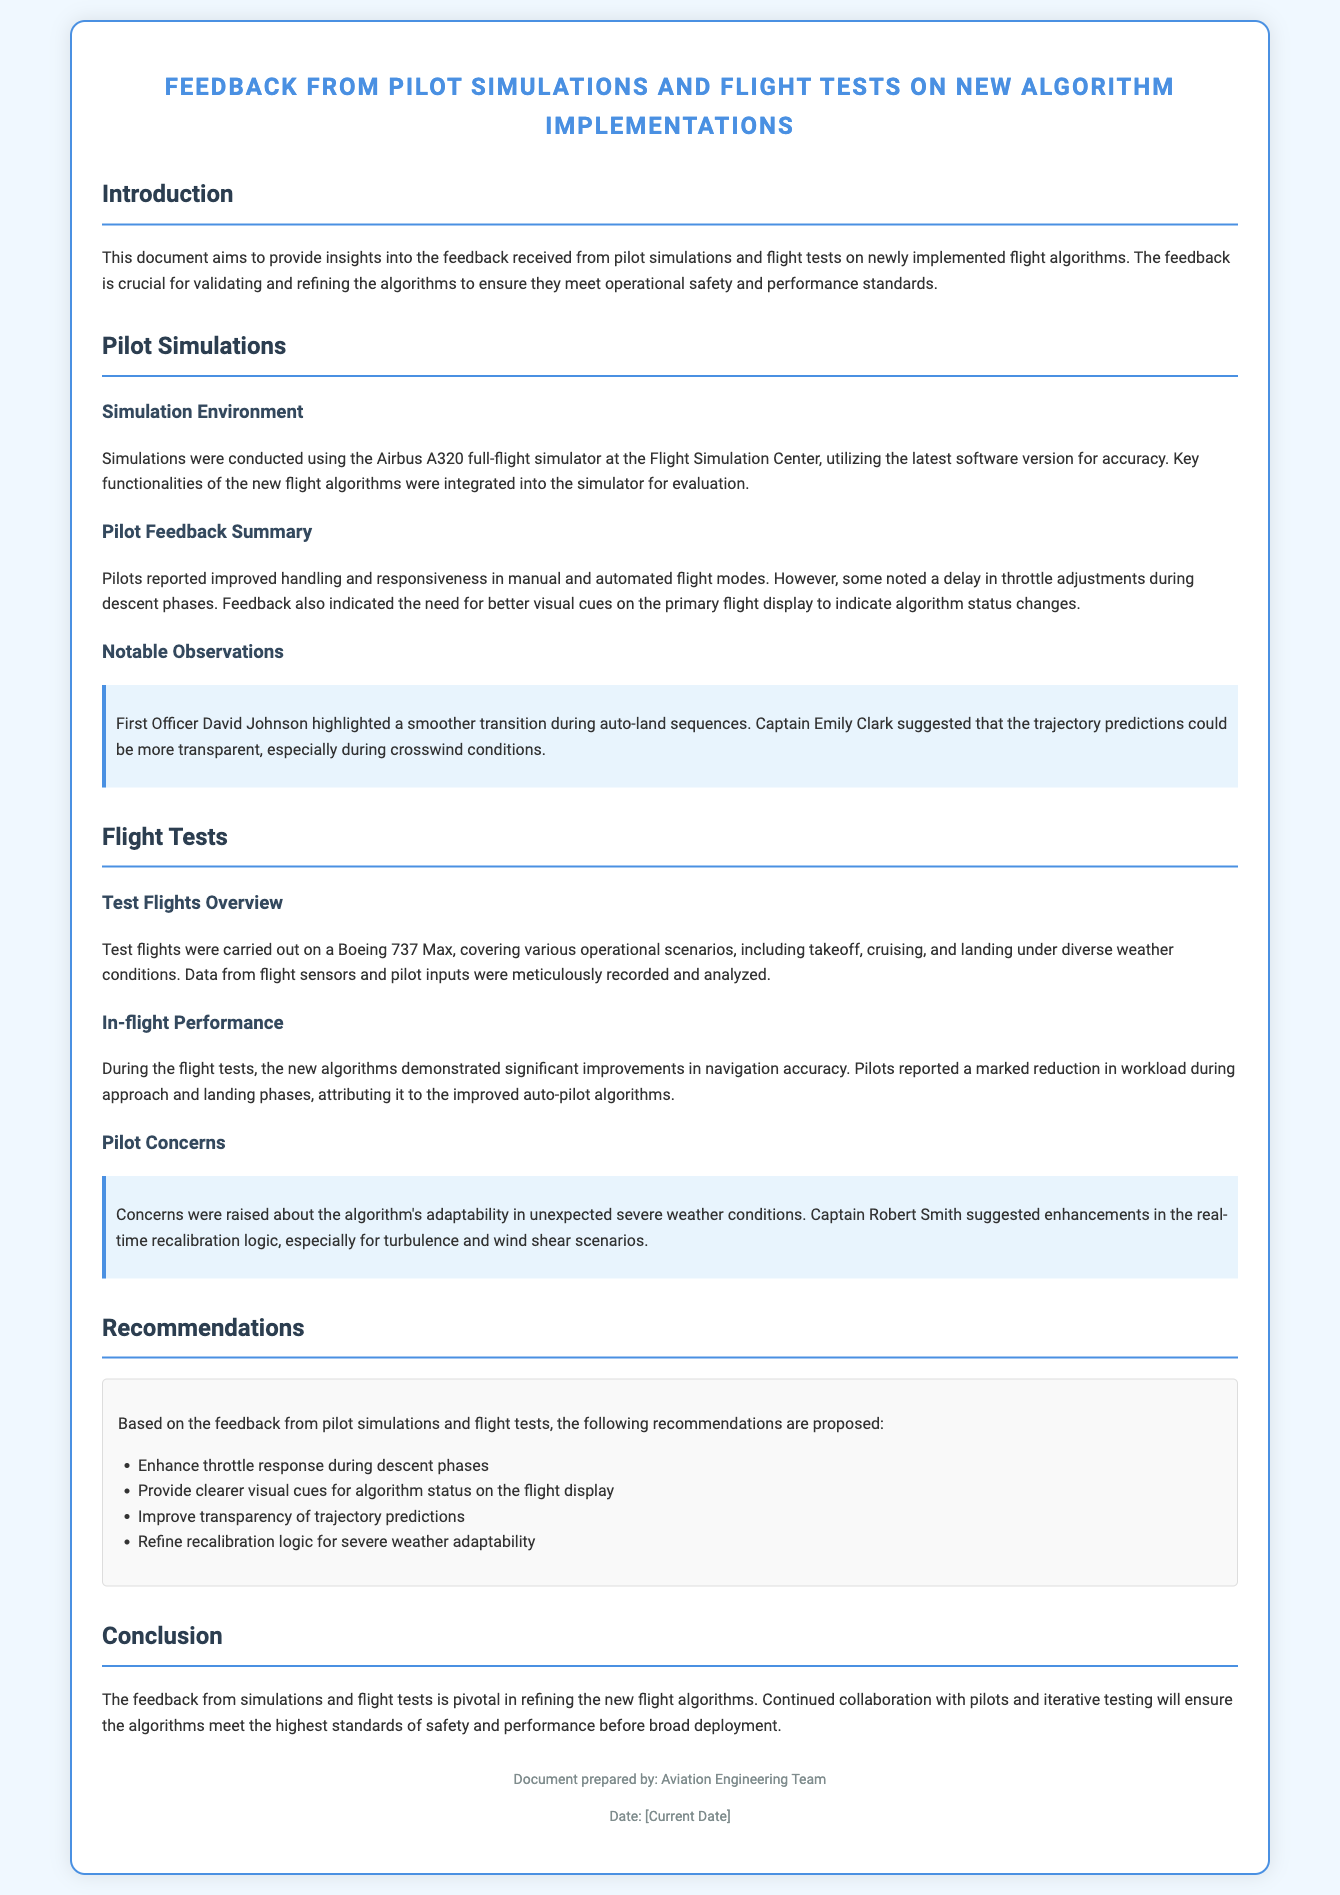What was the simulator used for the pilot simulations? The document states that simulations were conducted using the Airbus A320 full-flight simulator at the Flight Simulation Center.
Answer: Airbus A320 What improvement did pilots report in the algorithm's handling? The pilots reported improved handling and responsiveness in manual and automated flight modes.
Answer: Improved handling What was one pilot's concern during the flight tests? Captain Robert Smith raised concerns about the algorithm's adaptability in unexpected severe weather conditions.
Answer: Adaptability What feedback did First Officer David Johnson provide regarding auto-land sequences? First Officer David Johnson highlighted a smoother transition during auto-land sequences.
Answer: Smoother transition What type of weather scenarios were included in the flight tests? The document mentions that test flights covered various operational scenarios, including diverse weather conditions.
Answer: Diverse weather conditions How many recommendations are proposed based on the feedback? The document lists four recommendations based on the feedback from pilot simulations and flight tests.
Answer: Four recommendations What is the primary focus of this document? The document aims to provide insights into the feedback received from pilot simulations and flight tests on newly implemented flight algorithms.
Answer: Feedback insights What notable suggestion did Captain Emily Clark make? Captain Emily Clark suggested that the trajectory predictions could be more transparent, especially during crosswind conditions.
Answer: More transparent trajectory predictions 